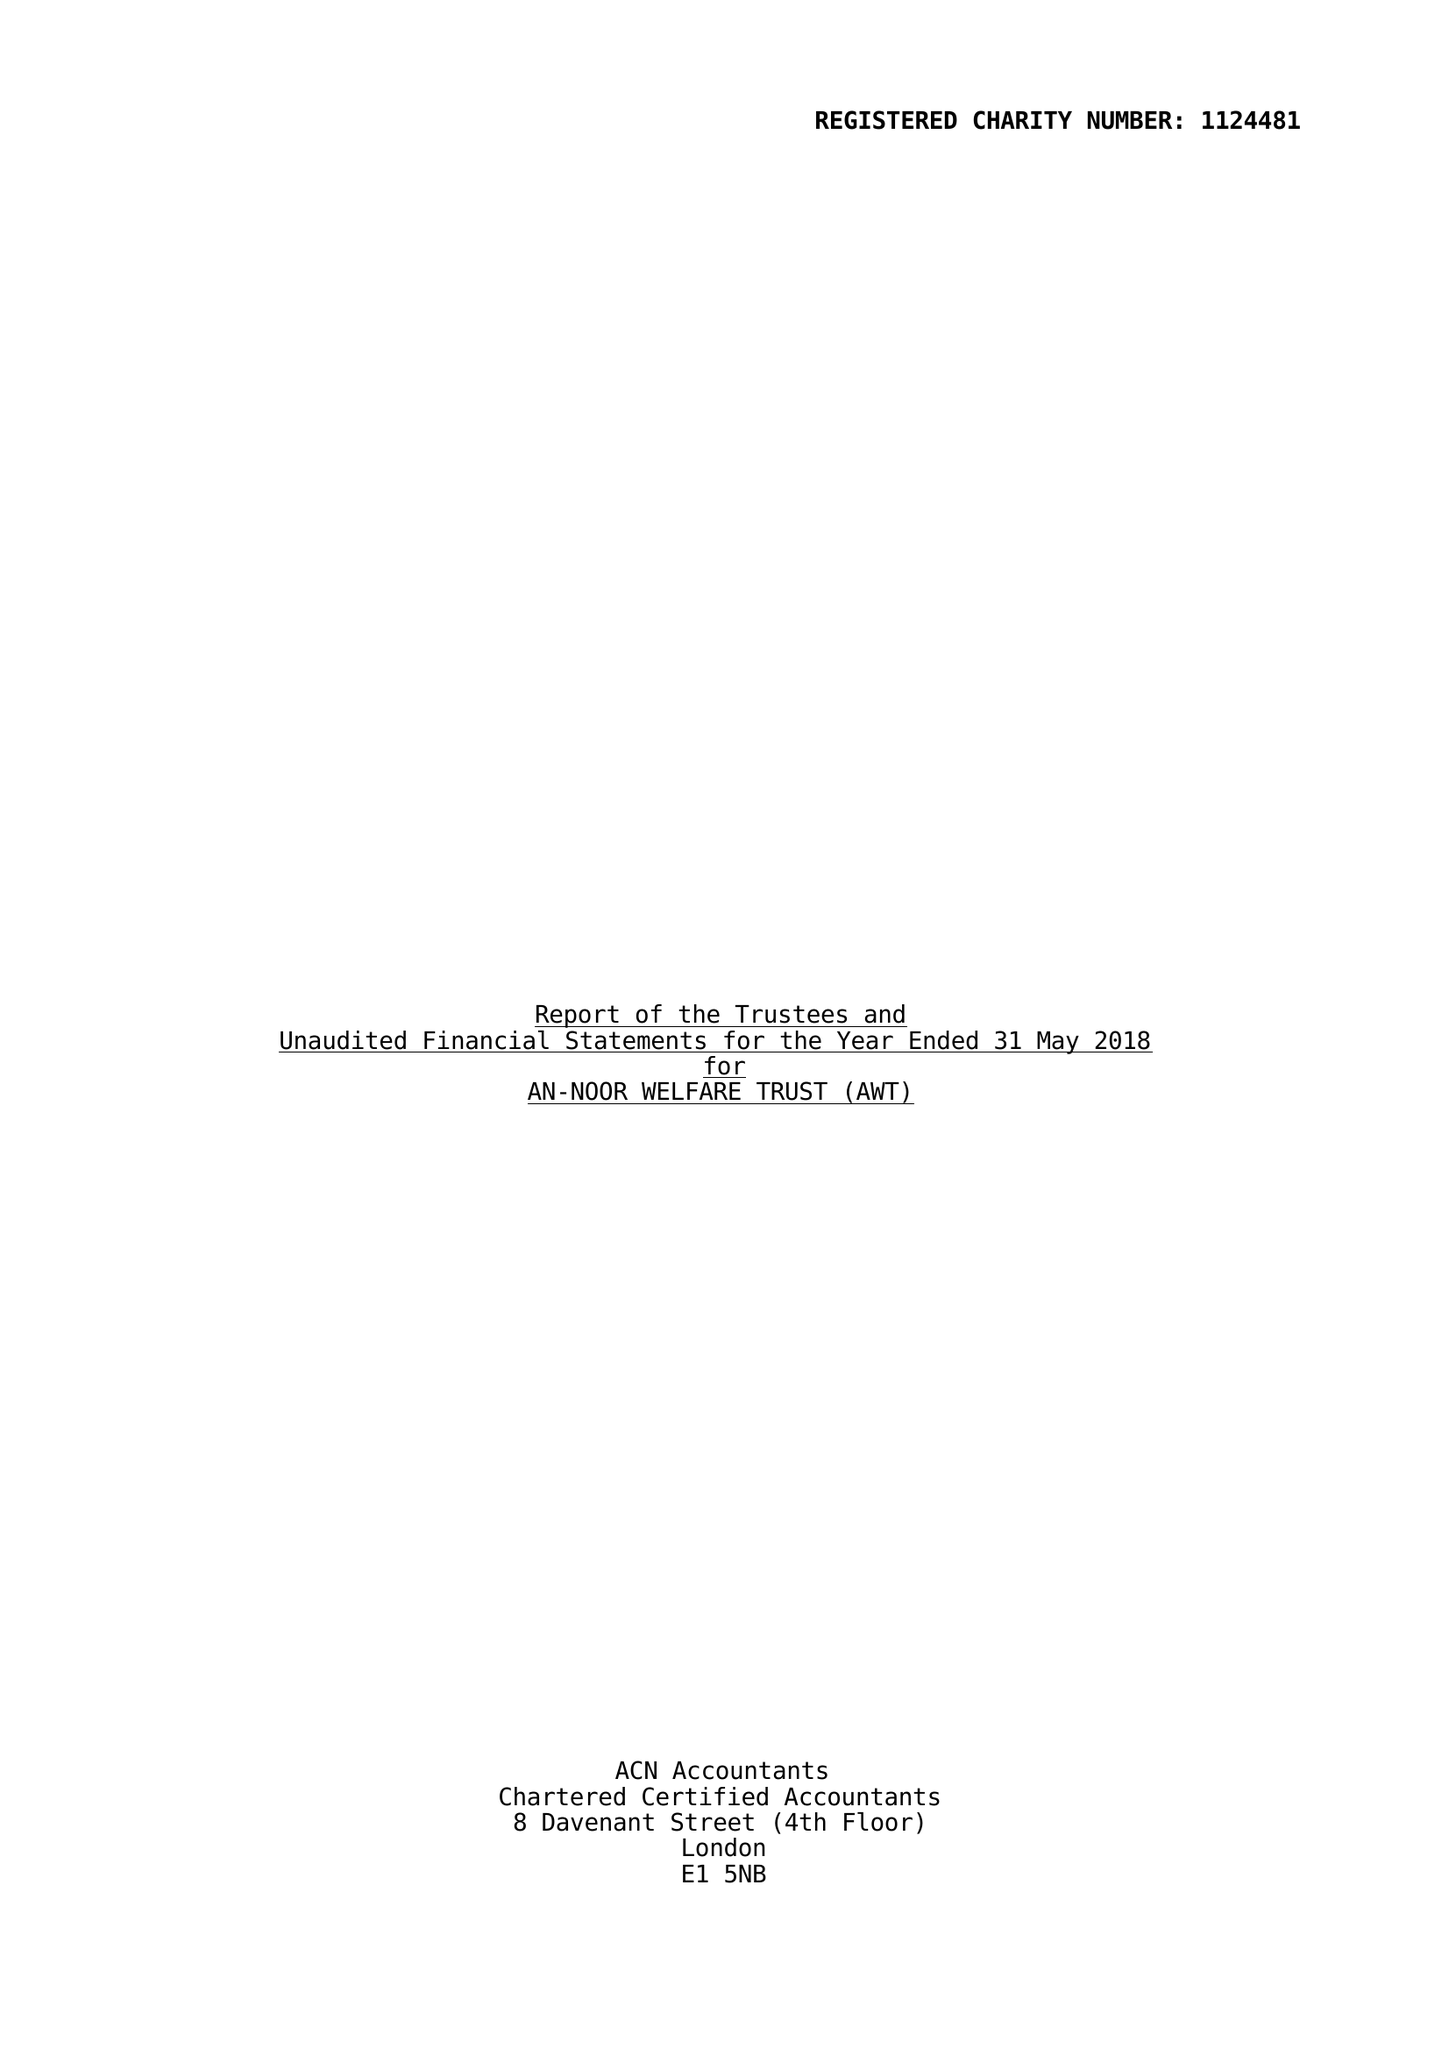What is the value for the income_annually_in_british_pounds?
Answer the question using a single word or phrase. 47841.00 